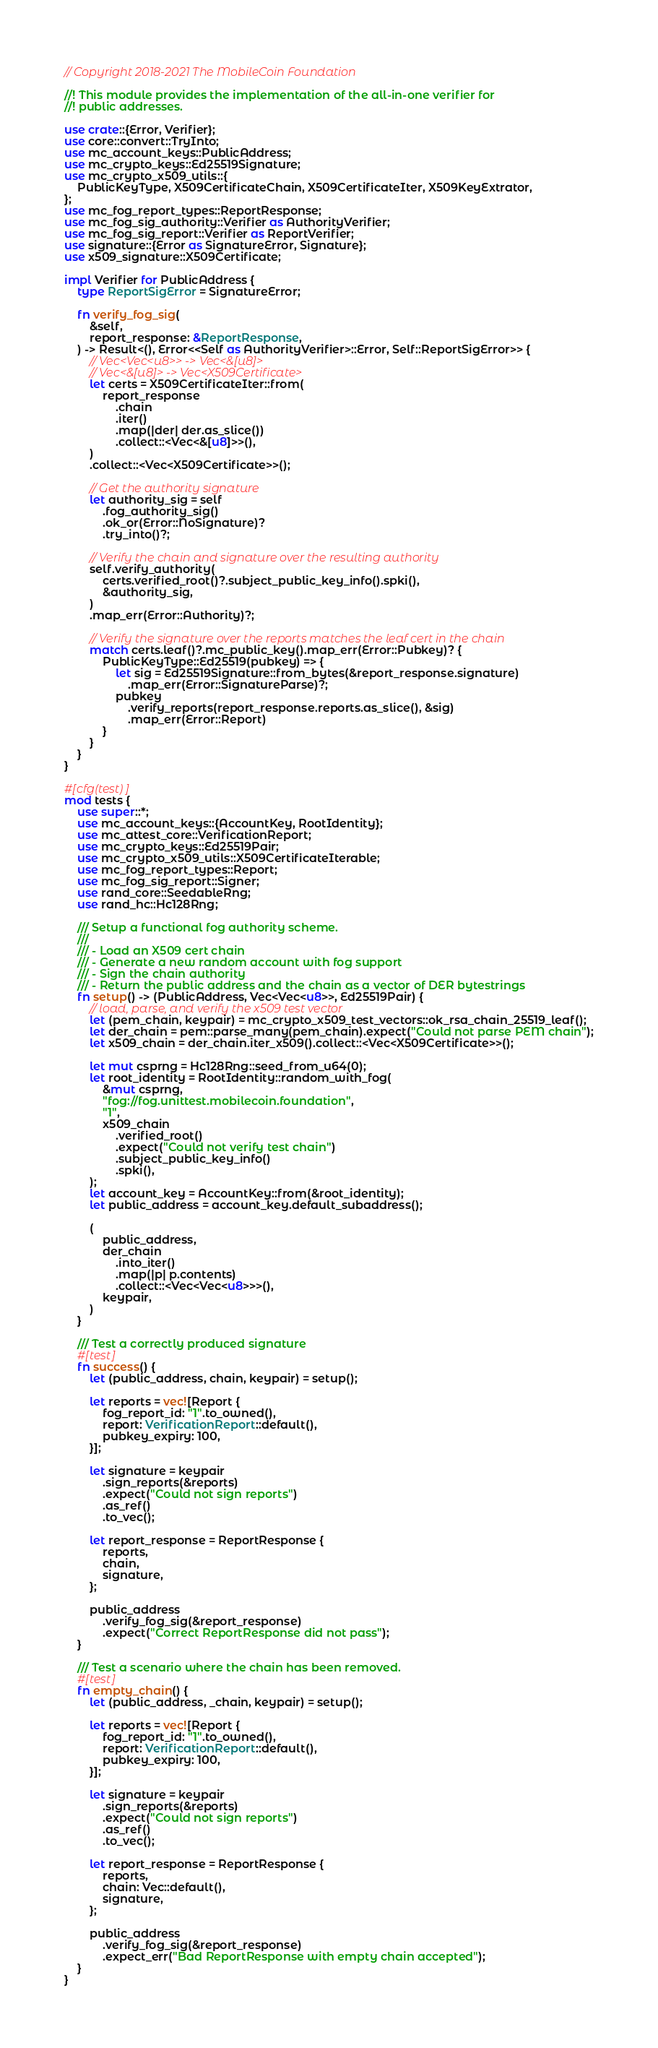<code> <loc_0><loc_0><loc_500><loc_500><_Rust_>// Copyright 2018-2021 The MobileCoin Foundation

//! This module provides the implementation of the all-in-one verifier for
//! public addresses.

use crate::{Error, Verifier};
use core::convert::TryInto;
use mc_account_keys::PublicAddress;
use mc_crypto_keys::Ed25519Signature;
use mc_crypto_x509_utils::{
    PublicKeyType, X509CertificateChain, X509CertificateIter, X509KeyExtrator,
};
use mc_fog_report_types::ReportResponse;
use mc_fog_sig_authority::Verifier as AuthorityVerifier;
use mc_fog_sig_report::Verifier as ReportVerifier;
use signature::{Error as SignatureError, Signature};
use x509_signature::X509Certificate;

impl Verifier for PublicAddress {
    type ReportSigError = SignatureError;

    fn verify_fog_sig(
        &self,
        report_response: &ReportResponse,
    ) -> Result<(), Error<<Self as AuthorityVerifier>::Error, Self::ReportSigError>> {
        // Vec<Vec<u8>> -> Vec<&[u8]>
        // Vec<&[u8]> -> Vec<X509Certificate>
        let certs = X509CertificateIter::from(
            report_response
                .chain
                .iter()
                .map(|der| der.as_slice())
                .collect::<Vec<&[u8]>>(),
        )
        .collect::<Vec<X509Certificate>>();

        // Get the authority signature
        let authority_sig = self
            .fog_authority_sig()
            .ok_or(Error::NoSignature)?
            .try_into()?;

        // Verify the chain and signature over the resulting authority
        self.verify_authority(
            certs.verified_root()?.subject_public_key_info().spki(),
            &authority_sig,
        )
        .map_err(Error::Authority)?;

        // Verify the signature over the reports matches the leaf cert in the chain
        match certs.leaf()?.mc_public_key().map_err(Error::Pubkey)? {
            PublicKeyType::Ed25519(pubkey) => {
                let sig = Ed25519Signature::from_bytes(&report_response.signature)
                    .map_err(Error::SignatureParse)?;
                pubkey
                    .verify_reports(report_response.reports.as_slice(), &sig)
                    .map_err(Error::Report)
            }
        }
    }
}

#[cfg(test)]
mod tests {
    use super::*;
    use mc_account_keys::{AccountKey, RootIdentity};
    use mc_attest_core::VerificationReport;
    use mc_crypto_keys::Ed25519Pair;
    use mc_crypto_x509_utils::X509CertificateIterable;
    use mc_fog_report_types::Report;
    use mc_fog_sig_report::Signer;
    use rand_core::SeedableRng;
    use rand_hc::Hc128Rng;

    /// Setup a functional fog authority scheme.
    ///
    /// - Load an X509 cert chain
    /// - Generate a new random account with fog support
    /// - Sign the chain authority
    /// - Return the public address and the chain as a vector of DER bytestrings
    fn setup() -> (PublicAddress, Vec<Vec<u8>>, Ed25519Pair) {
        // load, parse, and verify the x509 test vector
        let (pem_chain, keypair) = mc_crypto_x509_test_vectors::ok_rsa_chain_25519_leaf();
        let der_chain = pem::parse_many(pem_chain).expect("Could not parse PEM chain");
        let x509_chain = der_chain.iter_x509().collect::<Vec<X509Certificate>>();

        let mut csprng = Hc128Rng::seed_from_u64(0);
        let root_identity = RootIdentity::random_with_fog(
            &mut csprng,
            "fog://fog.unittest.mobilecoin.foundation",
            "1",
            x509_chain
                .verified_root()
                .expect("Could not verify test chain")
                .subject_public_key_info()
                .spki(),
        );
        let account_key = AccountKey::from(&root_identity);
        let public_address = account_key.default_subaddress();

        (
            public_address,
            der_chain
                .into_iter()
                .map(|p| p.contents)
                .collect::<Vec<Vec<u8>>>(),
            keypair,
        )
    }

    /// Test a correctly produced signature
    #[test]
    fn success() {
        let (public_address, chain, keypair) = setup();

        let reports = vec![Report {
            fog_report_id: "1".to_owned(),
            report: VerificationReport::default(),
            pubkey_expiry: 100,
        }];

        let signature = keypair
            .sign_reports(&reports)
            .expect("Could not sign reports")
            .as_ref()
            .to_vec();

        let report_response = ReportResponse {
            reports,
            chain,
            signature,
        };

        public_address
            .verify_fog_sig(&report_response)
            .expect("Correct ReportResponse did not pass");
    }

    /// Test a scenario where the chain has been removed.
    #[test]
    fn empty_chain() {
        let (public_address, _chain, keypair) = setup();

        let reports = vec![Report {
            fog_report_id: "1".to_owned(),
            report: VerificationReport::default(),
            pubkey_expiry: 100,
        }];

        let signature = keypair
            .sign_reports(&reports)
            .expect("Could not sign reports")
            .as_ref()
            .to_vec();

        let report_response = ReportResponse {
            reports,
            chain: Vec::default(),
            signature,
        };

        public_address
            .verify_fog_sig(&report_response)
            .expect_err("Bad ReportResponse with empty chain accepted");
    }
}
</code> 